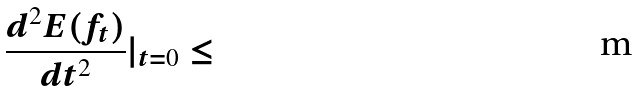<formula> <loc_0><loc_0><loc_500><loc_500>\frac { d ^ { 2 } E ( f _ { t } ) } { d t ^ { 2 } } | _ { t = 0 } \leq</formula> 